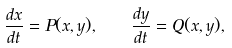<formula> <loc_0><loc_0><loc_500><loc_500>\frac { d x } { d t } = P ( x , y ) , \quad \frac { d y } { d t } = Q ( x , y ) ,</formula> 